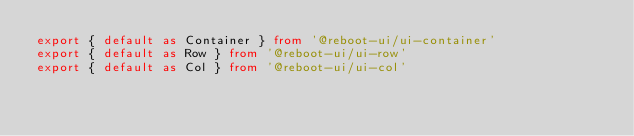<code> <loc_0><loc_0><loc_500><loc_500><_TypeScript_>export { default as Container } from '@reboot-ui/ui-container'
export { default as Row } from '@reboot-ui/ui-row'
export { default as Col } from '@reboot-ui/ui-col'</code> 